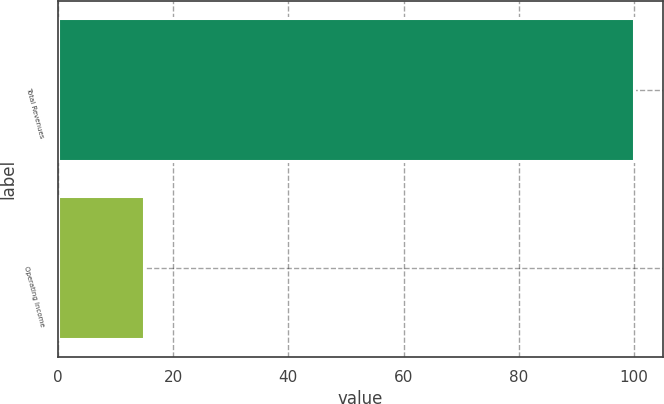<chart> <loc_0><loc_0><loc_500><loc_500><bar_chart><fcel>Total Revenues<fcel>Operating Income<nl><fcel>100<fcel>15<nl></chart> 